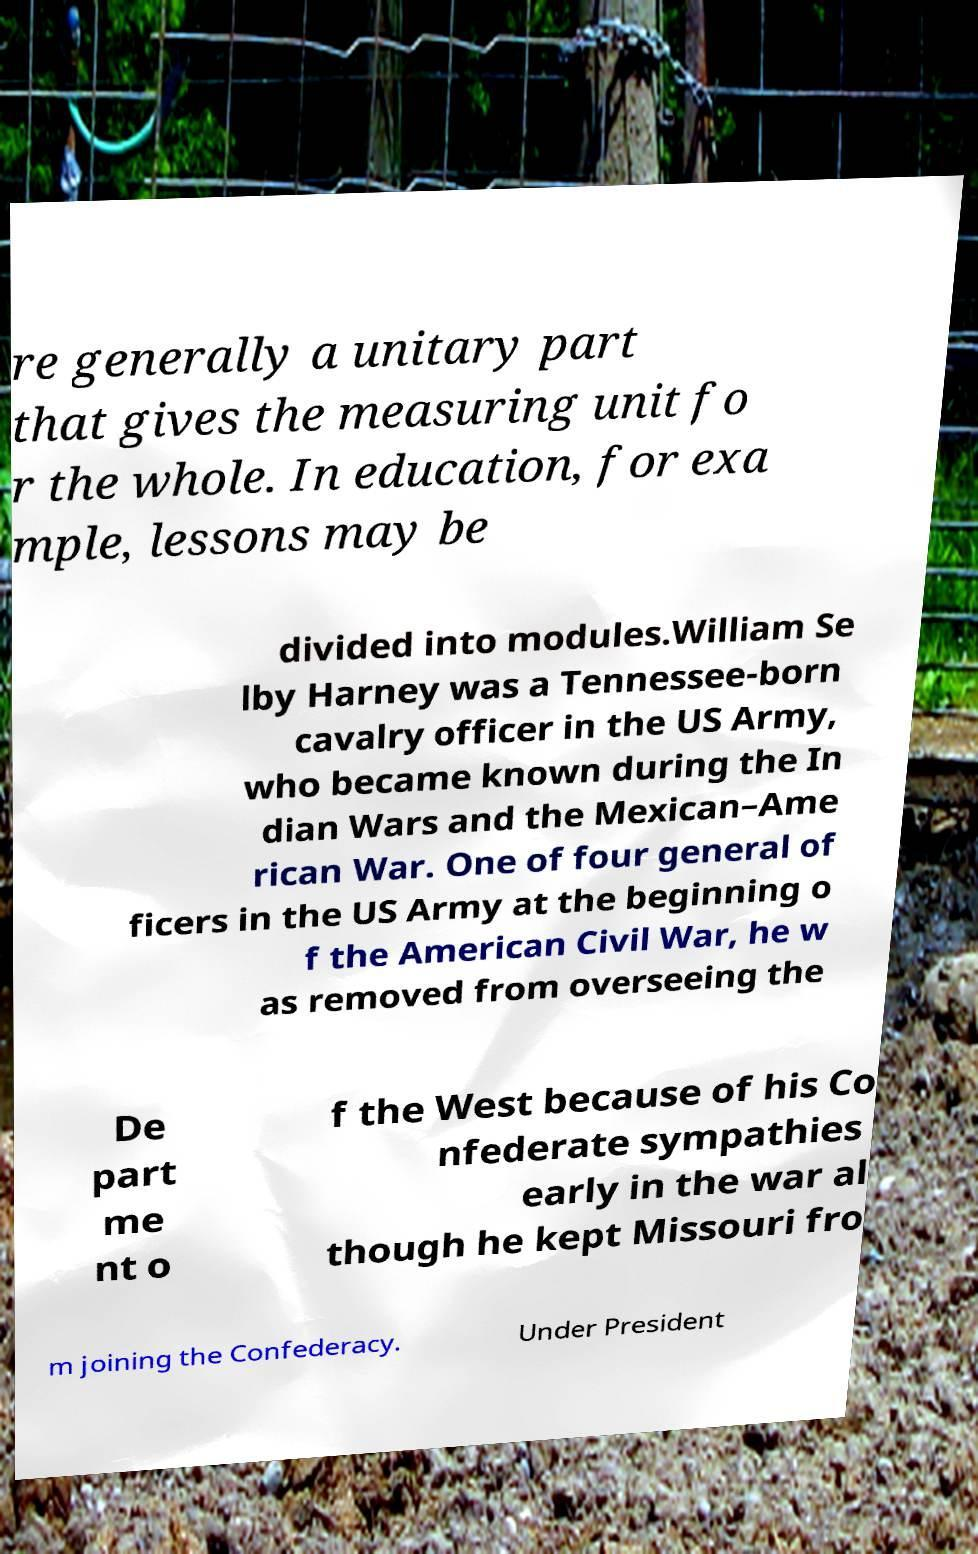What messages or text are displayed in this image? I need them in a readable, typed format. re generally a unitary part that gives the measuring unit fo r the whole. In education, for exa mple, lessons may be divided into modules.William Se lby Harney was a Tennessee-born cavalry officer in the US Army, who became known during the In dian Wars and the Mexican–Ame rican War. One of four general of ficers in the US Army at the beginning o f the American Civil War, he w as removed from overseeing the De part me nt o f the West because of his Co nfederate sympathies early in the war al though he kept Missouri fro m joining the Confederacy. Under President 